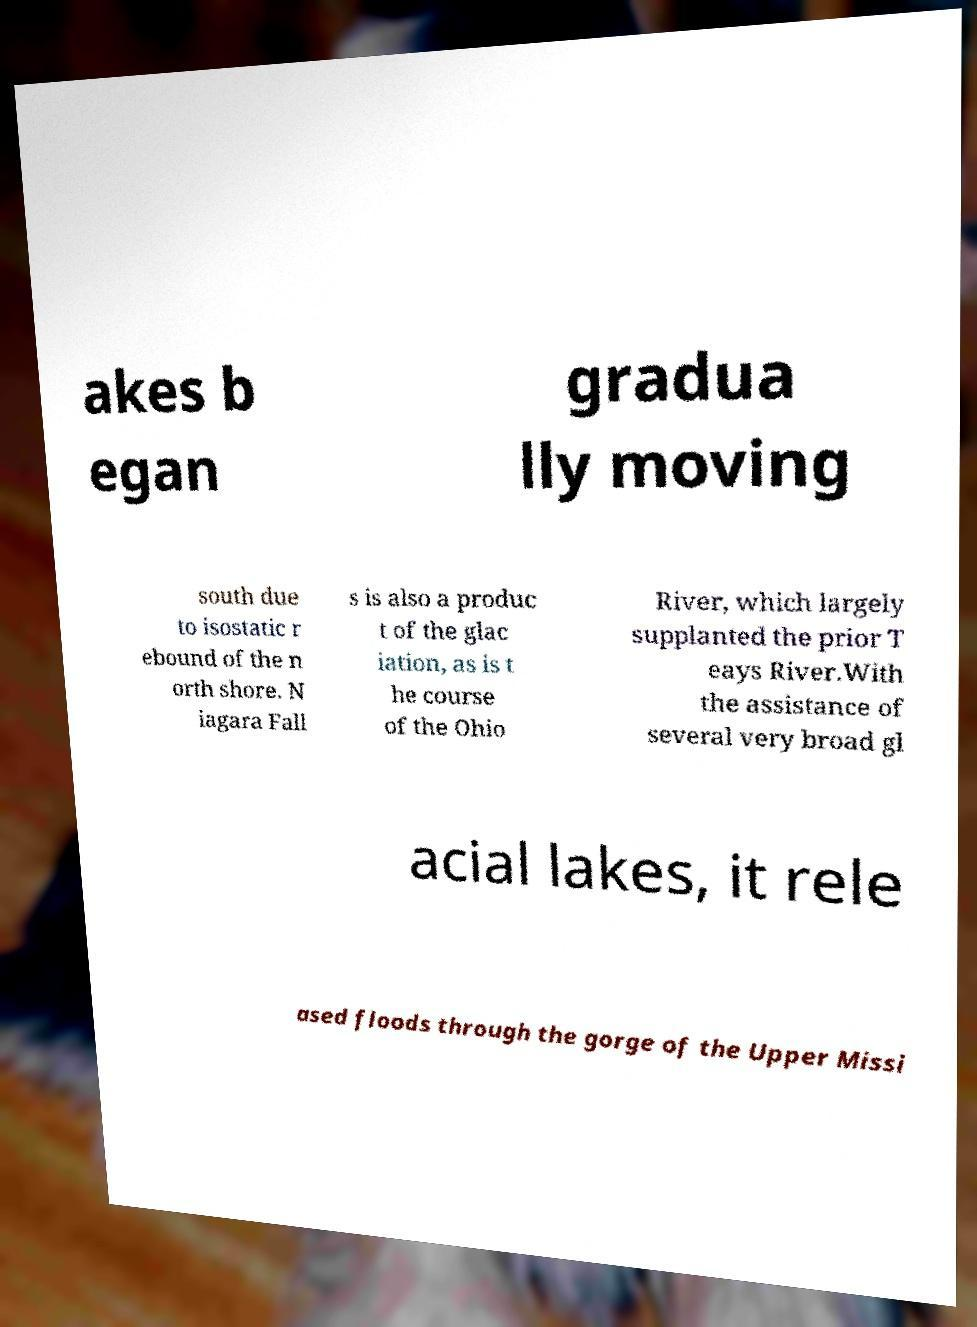Can you accurately transcribe the text from the provided image for me? akes b egan gradua lly moving south due to isostatic r ebound of the n orth shore. N iagara Fall s is also a produc t of the glac iation, as is t he course of the Ohio River, which largely supplanted the prior T eays River.With the assistance of several very broad gl acial lakes, it rele ased floods through the gorge of the Upper Missi 